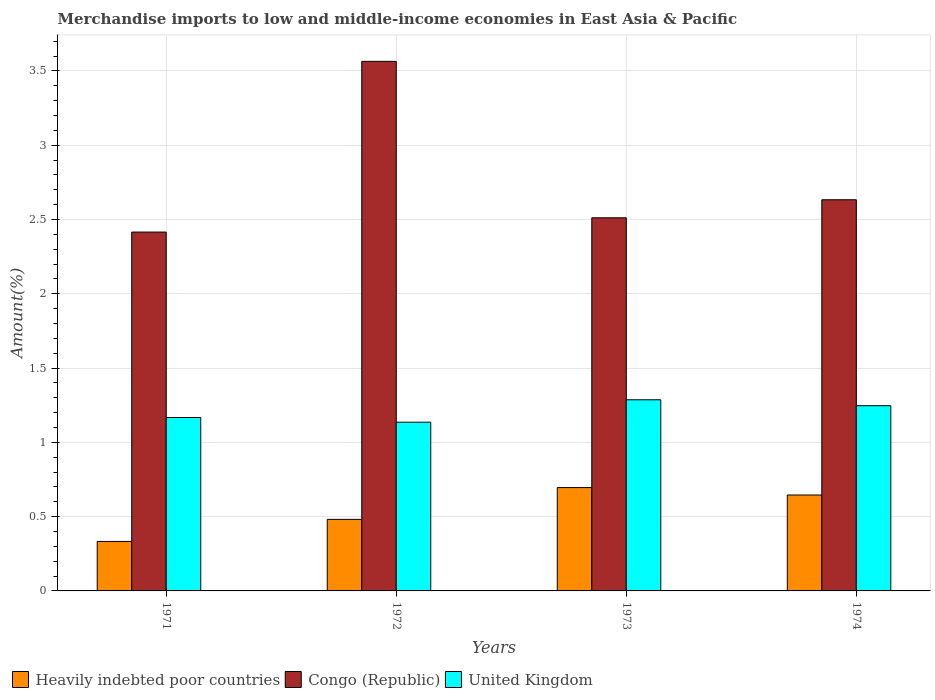How many groups of bars are there?
Your response must be concise. 4. Are the number of bars per tick equal to the number of legend labels?
Offer a terse response. Yes. How many bars are there on the 3rd tick from the left?
Give a very brief answer. 3. How many bars are there on the 1st tick from the right?
Your answer should be very brief. 3. What is the percentage of amount earned from merchandise imports in Congo (Republic) in 1972?
Your answer should be very brief. 3.56. Across all years, what is the maximum percentage of amount earned from merchandise imports in Congo (Republic)?
Ensure brevity in your answer.  3.56. Across all years, what is the minimum percentage of amount earned from merchandise imports in Heavily indebted poor countries?
Offer a terse response. 0.33. In which year was the percentage of amount earned from merchandise imports in Congo (Republic) minimum?
Make the answer very short. 1971. What is the total percentage of amount earned from merchandise imports in United Kingdom in the graph?
Provide a succinct answer. 4.84. What is the difference between the percentage of amount earned from merchandise imports in Congo (Republic) in 1972 and that in 1974?
Make the answer very short. 0.93. What is the difference between the percentage of amount earned from merchandise imports in United Kingdom in 1973 and the percentage of amount earned from merchandise imports in Heavily indebted poor countries in 1974?
Offer a terse response. 0.64. What is the average percentage of amount earned from merchandise imports in Heavily indebted poor countries per year?
Give a very brief answer. 0.54. In the year 1973, what is the difference between the percentage of amount earned from merchandise imports in United Kingdom and percentage of amount earned from merchandise imports in Heavily indebted poor countries?
Ensure brevity in your answer.  0.59. In how many years, is the percentage of amount earned from merchandise imports in Heavily indebted poor countries greater than 0.6 %?
Offer a terse response. 2. What is the ratio of the percentage of amount earned from merchandise imports in Congo (Republic) in 1971 to that in 1974?
Provide a succinct answer. 0.92. Is the difference between the percentage of amount earned from merchandise imports in United Kingdom in 1972 and 1974 greater than the difference between the percentage of amount earned from merchandise imports in Heavily indebted poor countries in 1972 and 1974?
Your answer should be compact. Yes. What is the difference between the highest and the second highest percentage of amount earned from merchandise imports in United Kingdom?
Ensure brevity in your answer.  0.04. What is the difference between the highest and the lowest percentage of amount earned from merchandise imports in Congo (Republic)?
Make the answer very short. 1.15. In how many years, is the percentage of amount earned from merchandise imports in Heavily indebted poor countries greater than the average percentage of amount earned from merchandise imports in Heavily indebted poor countries taken over all years?
Provide a short and direct response. 2. Is the sum of the percentage of amount earned from merchandise imports in Congo (Republic) in 1973 and 1974 greater than the maximum percentage of amount earned from merchandise imports in United Kingdom across all years?
Provide a succinct answer. Yes. What does the 2nd bar from the left in 1973 represents?
Provide a short and direct response. Congo (Republic). What does the 2nd bar from the right in 1972 represents?
Make the answer very short. Congo (Republic). Is it the case that in every year, the sum of the percentage of amount earned from merchandise imports in Heavily indebted poor countries and percentage of amount earned from merchandise imports in United Kingdom is greater than the percentage of amount earned from merchandise imports in Congo (Republic)?
Ensure brevity in your answer.  No. How many bars are there?
Keep it short and to the point. 12. How many years are there in the graph?
Your answer should be compact. 4. What is the difference between two consecutive major ticks on the Y-axis?
Your answer should be compact. 0.5. Are the values on the major ticks of Y-axis written in scientific E-notation?
Make the answer very short. No. Does the graph contain any zero values?
Ensure brevity in your answer.  No. Does the graph contain grids?
Offer a very short reply. Yes. Where does the legend appear in the graph?
Keep it short and to the point. Bottom left. How are the legend labels stacked?
Offer a terse response. Horizontal. What is the title of the graph?
Ensure brevity in your answer.  Merchandise imports to low and middle-income economies in East Asia & Pacific. Does "Euro area" appear as one of the legend labels in the graph?
Make the answer very short. No. What is the label or title of the X-axis?
Keep it short and to the point. Years. What is the label or title of the Y-axis?
Provide a short and direct response. Amount(%). What is the Amount(%) of Heavily indebted poor countries in 1971?
Provide a succinct answer. 0.33. What is the Amount(%) in Congo (Republic) in 1971?
Your answer should be very brief. 2.42. What is the Amount(%) of United Kingdom in 1971?
Give a very brief answer. 1.17. What is the Amount(%) of Heavily indebted poor countries in 1972?
Keep it short and to the point. 0.48. What is the Amount(%) in Congo (Republic) in 1972?
Offer a very short reply. 3.56. What is the Amount(%) in United Kingdom in 1972?
Provide a short and direct response. 1.14. What is the Amount(%) of Heavily indebted poor countries in 1973?
Ensure brevity in your answer.  0.7. What is the Amount(%) in Congo (Republic) in 1973?
Provide a short and direct response. 2.51. What is the Amount(%) in United Kingdom in 1973?
Your answer should be compact. 1.29. What is the Amount(%) of Heavily indebted poor countries in 1974?
Offer a very short reply. 0.65. What is the Amount(%) in Congo (Republic) in 1974?
Make the answer very short. 2.63. What is the Amount(%) of United Kingdom in 1974?
Offer a very short reply. 1.25. Across all years, what is the maximum Amount(%) of Heavily indebted poor countries?
Keep it short and to the point. 0.7. Across all years, what is the maximum Amount(%) in Congo (Republic)?
Your answer should be very brief. 3.56. Across all years, what is the maximum Amount(%) of United Kingdom?
Your response must be concise. 1.29. Across all years, what is the minimum Amount(%) of Heavily indebted poor countries?
Offer a very short reply. 0.33. Across all years, what is the minimum Amount(%) of Congo (Republic)?
Your response must be concise. 2.42. Across all years, what is the minimum Amount(%) in United Kingdom?
Give a very brief answer. 1.14. What is the total Amount(%) in Heavily indebted poor countries in the graph?
Offer a terse response. 2.16. What is the total Amount(%) in Congo (Republic) in the graph?
Keep it short and to the point. 11.12. What is the total Amount(%) in United Kingdom in the graph?
Your answer should be compact. 4.84. What is the difference between the Amount(%) in Heavily indebted poor countries in 1971 and that in 1972?
Provide a short and direct response. -0.15. What is the difference between the Amount(%) in Congo (Republic) in 1971 and that in 1972?
Make the answer very short. -1.15. What is the difference between the Amount(%) in United Kingdom in 1971 and that in 1972?
Provide a short and direct response. 0.03. What is the difference between the Amount(%) of Heavily indebted poor countries in 1971 and that in 1973?
Keep it short and to the point. -0.36. What is the difference between the Amount(%) in Congo (Republic) in 1971 and that in 1973?
Give a very brief answer. -0.1. What is the difference between the Amount(%) of United Kingdom in 1971 and that in 1973?
Give a very brief answer. -0.12. What is the difference between the Amount(%) of Heavily indebted poor countries in 1971 and that in 1974?
Make the answer very short. -0.31. What is the difference between the Amount(%) in Congo (Republic) in 1971 and that in 1974?
Offer a very short reply. -0.22. What is the difference between the Amount(%) of United Kingdom in 1971 and that in 1974?
Keep it short and to the point. -0.08. What is the difference between the Amount(%) of Heavily indebted poor countries in 1972 and that in 1973?
Give a very brief answer. -0.21. What is the difference between the Amount(%) of Congo (Republic) in 1972 and that in 1973?
Give a very brief answer. 1.05. What is the difference between the Amount(%) of United Kingdom in 1972 and that in 1973?
Give a very brief answer. -0.15. What is the difference between the Amount(%) of Heavily indebted poor countries in 1972 and that in 1974?
Your answer should be very brief. -0.16. What is the difference between the Amount(%) in Congo (Republic) in 1972 and that in 1974?
Offer a terse response. 0.93. What is the difference between the Amount(%) of United Kingdom in 1972 and that in 1974?
Offer a terse response. -0.11. What is the difference between the Amount(%) of Heavily indebted poor countries in 1973 and that in 1974?
Keep it short and to the point. 0.05. What is the difference between the Amount(%) of Congo (Republic) in 1973 and that in 1974?
Your answer should be compact. -0.12. What is the difference between the Amount(%) of United Kingdom in 1973 and that in 1974?
Ensure brevity in your answer.  0.04. What is the difference between the Amount(%) of Heavily indebted poor countries in 1971 and the Amount(%) of Congo (Republic) in 1972?
Your answer should be compact. -3.23. What is the difference between the Amount(%) in Heavily indebted poor countries in 1971 and the Amount(%) in United Kingdom in 1972?
Your answer should be very brief. -0.8. What is the difference between the Amount(%) of Congo (Republic) in 1971 and the Amount(%) of United Kingdom in 1972?
Your response must be concise. 1.28. What is the difference between the Amount(%) of Heavily indebted poor countries in 1971 and the Amount(%) of Congo (Republic) in 1973?
Ensure brevity in your answer.  -2.18. What is the difference between the Amount(%) in Heavily indebted poor countries in 1971 and the Amount(%) in United Kingdom in 1973?
Your answer should be very brief. -0.95. What is the difference between the Amount(%) in Congo (Republic) in 1971 and the Amount(%) in United Kingdom in 1973?
Make the answer very short. 1.13. What is the difference between the Amount(%) in Heavily indebted poor countries in 1971 and the Amount(%) in Congo (Republic) in 1974?
Offer a terse response. -2.3. What is the difference between the Amount(%) in Heavily indebted poor countries in 1971 and the Amount(%) in United Kingdom in 1974?
Make the answer very short. -0.91. What is the difference between the Amount(%) of Congo (Republic) in 1971 and the Amount(%) of United Kingdom in 1974?
Provide a succinct answer. 1.17. What is the difference between the Amount(%) of Heavily indebted poor countries in 1972 and the Amount(%) of Congo (Republic) in 1973?
Offer a terse response. -2.03. What is the difference between the Amount(%) in Heavily indebted poor countries in 1972 and the Amount(%) in United Kingdom in 1973?
Your response must be concise. -0.8. What is the difference between the Amount(%) in Congo (Republic) in 1972 and the Amount(%) in United Kingdom in 1973?
Ensure brevity in your answer.  2.28. What is the difference between the Amount(%) of Heavily indebted poor countries in 1972 and the Amount(%) of Congo (Republic) in 1974?
Your answer should be compact. -2.15. What is the difference between the Amount(%) of Heavily indebted poor countries in 1972 and the Amount(%) of United Kingdom in 1974?
Ensure brevity in your answer.  -0.77. What is the difference between the Amount(%) in Congo (Republic) in 1972 and the Amount(%) in United Kingdom in 1974?
Your response must be concise. 2.32. What is the difference between the Amount(%) of Heavily indebted poor countries in 1973 and the Amount(%) of Congo (Republic) in 1974?
Your answer should be compact. -1.94. What is the difference between the Amount(%) in Heavily indebted poor countries in 1973 and the Amount(%) in United Kingdom in 1974?
Provide a short and direct response. -0.55. What is the difference between the Amount(%) in Congo (Republic) in 1973 and the Amount(%) in United Kingdom in 1974?
Ensure brevity in your answer.  1.26. What is the average Amount(%) in Heavily indebted poor countries per year?
Make the answer very short. 0.54. What is the average Amount(%) in Congo (Republic) per year?
Make the answer very short. 2.78. What is the average Amount(%) of United Kingdom per year?
Provide a short and direct response. 1.21. In the year 1971, what is the difference between the Amount(%) of Heavily indebted poor countries and Amount(%) of Congo (Republic)?
Provide a succinct answer. -2.08. In the year 1971, what is the difference between the Amount(%) in Heavily indebted poor countries and Amount(%) in United Kingdom?
Your answer should be very brief. -0.83. In the year 1971, what is the difference between the Amount(%) of Congo (Republic) and Amount(%) of United Kingdom?
Your answer should be very brief. 1.25. In the year 1972, what is the difference between the Amount(%) in Heavily indebted poor countries and Amount(%) in Congo (Republic)?
Make the answer very short. -3.08. In the year 1972, what is the difference between the Amount(%) of Heavily indebted poor countries and Amount(%) of United Kingdom?
Ensure brevity in your answer.  -0.65. In the year 1972, what is the difference between the Amount(%) of Congo (Republic) and Amount(%) of United Kingdom?
Your answer should be very brief. 2.43. In the year 1973, what is the difference between the Amount(%) of Heavily indebted poor countries and Amount(%) of Congo (Republic)?
Your answer should be compact. -1.82. In the year 1973, what is the difference between the Amount(%) of Heavily indebted poor countries and Amount(%) of United Kingdom?
Ensure brevity in your answer.  -0.59. In the year 1973, what is the difference between the Amount(%) of Congo (Republic) and Amount(%) of United Kingdom?
Offer a terse response. 1.22. In the year 1974, what is the difference between the Amount(%) in Heavily indebted poor countries and Amount(%) in Congo (Republic)?
Provide a short and direct response. -1.99. In the year 1974, what is the difference between the Amount(%) in Heavily indebted poor countries and Amount(%) in United Kingdom?
Provide a short and direct response. -0.6. In the year 1974, what is the difference between the Amount(%) in Congo (Republic) and Amount(%) in United Kingdom?
Ensure brevity in your answer.  1.39. What is the ratio of the Amount(%) of Heavily indebted poor countries in 1971 to that in 1972?
Your response must be concise. 0.69. What is the ratio of the Amount(%) in Congo (Republic) in 1971 to that in 1972?
Your response must be concise. 0.68. What is the ratio of the Amount(%) in United Kingdom in 1971 to that in 1972?
Keep it short and to the point. 1.03. What is the ratio of the Amount(%) in Heavily indebted poor countries in 1971 to that in 1973?
Offer a terse response. 0.48. What is the ratio of the Amount(%) in Congo (Republic) in 1971 to that in 1973?
Give a very brief answer. 0.96. What is the ratio of the Amount(%) of United Kingdom in 1971 to that in 1973?
Ensure brevity in your answer.  0.91. What is the ratio of the Amount(%) in Heavily indebted poor countries in 1971 to that in 1974?
Offer a terse response. 0.52. What is the ratio of the Amount(%) in Congo (Republic) in 1971 to that in 1974?
Keep it short and to the point. 0.92. What is the ratio of the Amount(%) of United Kingdom in 1971 to that in 1974?
Your answer should be compact. 0.94. What is the ratio of the Amount(%) of Heavily indebted poor countries in 1972 to that in 1973?
Offer a very short reply. 0.69. What is the ratio of the Amount(%) in Congo (Republic) in 1972 to that in 1973?
Offer a very short reply. 1.42. What is the ratio of the Amount(%) of United Kingdom in 1972 to that in 1973?
Ensure brevity in your answer.  0.88. What is the ratio of the Amount(%) in Heavily indebted poor countries in 1972 to that in 1974?
Your answer should be very brief. 0.75. What is the ratio of the Amount(%) of Congo (Republic) in 1972 to that in 1974?
Offer a terse response. 1.35. What is the ratio of the Amount(%) in United Kingdom in 1972 to that in 1974?
Your answer should be very brief. 0.91. What is the ratio of the Amount(%) of Heavily indebted poor countries in 1973 to that in 1974?
Your answer should be compact. 1.08. What is the ratio of the Amount(%) in Congo (Republic) in 1973 to that in 1974?
Provide a short and direct response. 0.95. What is the ratio of the Amount(%) in United Kingdom in 1973 to that in 1974?
Provide a succinct answer. 1.03. What is the difference between the highest and the second highest Amount(%) in Heavily indebted poor countries?
Offer a very short reply. 0.05. What is the difference between the highest and the second highest Amount(%) in Congo (Republic)?
Offer a very short reply. 0.93. What is the difference between the highest and the second highest Amount(%) in United Kingdom?
Your response must be concise. 0.04. What is the difference between the highest and the lowest Amount(%) of Heavily indebted poor countries?
Provide a succinct answer. 0.36. What is the difference between the highest and the lowest Amount(%) in Congo (Republic)?
Offer a very short reply. 1.15. What is the difference between the highest and the lowest Amount(%) of United Kingdom?
Your answer should be very brief. 0.15. 